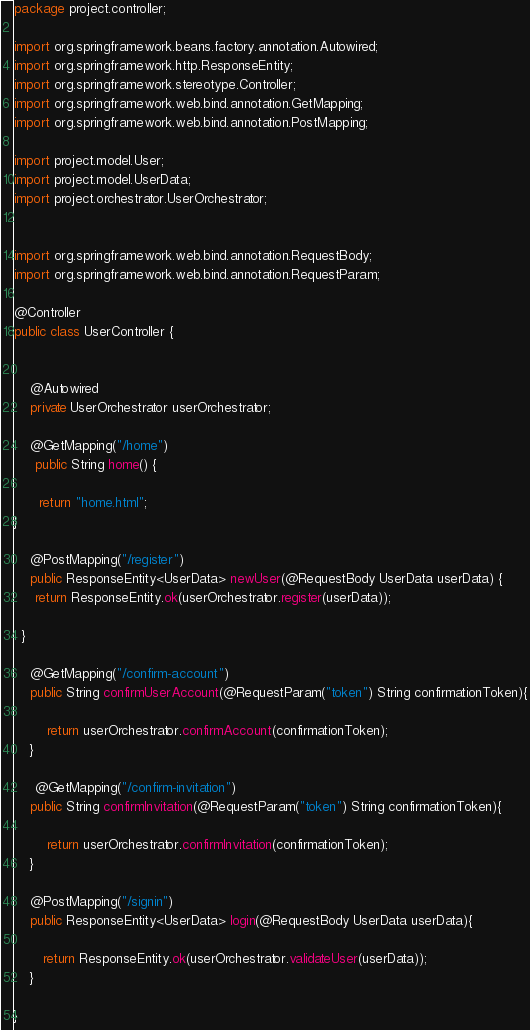<code> <loc_0><loc_0><loc_500><loc_500><_Java_>package project.controller;

import org.springframework.beans.factory.annotation.Autowired;
import org.springframework.http.ResponseEntity;
import org.springframework.stereotype.Controller;
import org.springframework.web.bind.annotation.GetMapping;
import org.springframework.web.bind.annotation.PostMapping;

import project.model.User;
import project.model.UserData;
import project.orchestrator.UserOrchestrator;


import org.springframework.web.bind.annotation.RequestBody;
import org.springframework.web.bind.annotation.RequestParam;
   
@Controller
public class UserController {


    @Autowired
    private UserOrchestrator userOrchestrator;
    
    @GetMapping("/home")
     public String home() {

      return "home.html";
}
    
    @PostMapping("/register")
    public ResponseEntity<UserData> newUser(@RequestBody UserData userData) {
     return ResponseEntity.ok(userOrchestrator.register(userData));
     
  }
    
    @GetMapping("/confirm-account")
    public String confirmUserAccount(@RequestParam("token") String confirmationToken){
        
        return userOrchestrator.confirmAccount(confirmationToken);
    }
    
     @GetMapping("/confirm-invitation")
    public String confirmInvitation(@RequestParam("token") String confirmationToken){
        
        return userOrchestrator.confirmInvitation(confirmationToken);
    }
    
    @PostMapping("/signin")
    public ResponseEntity<UserData> login(@RequestBody UserData userData){
        
       return ResponseEntity.ok(userOrchestrator.validateUser(userData));
    }

}
</code> 